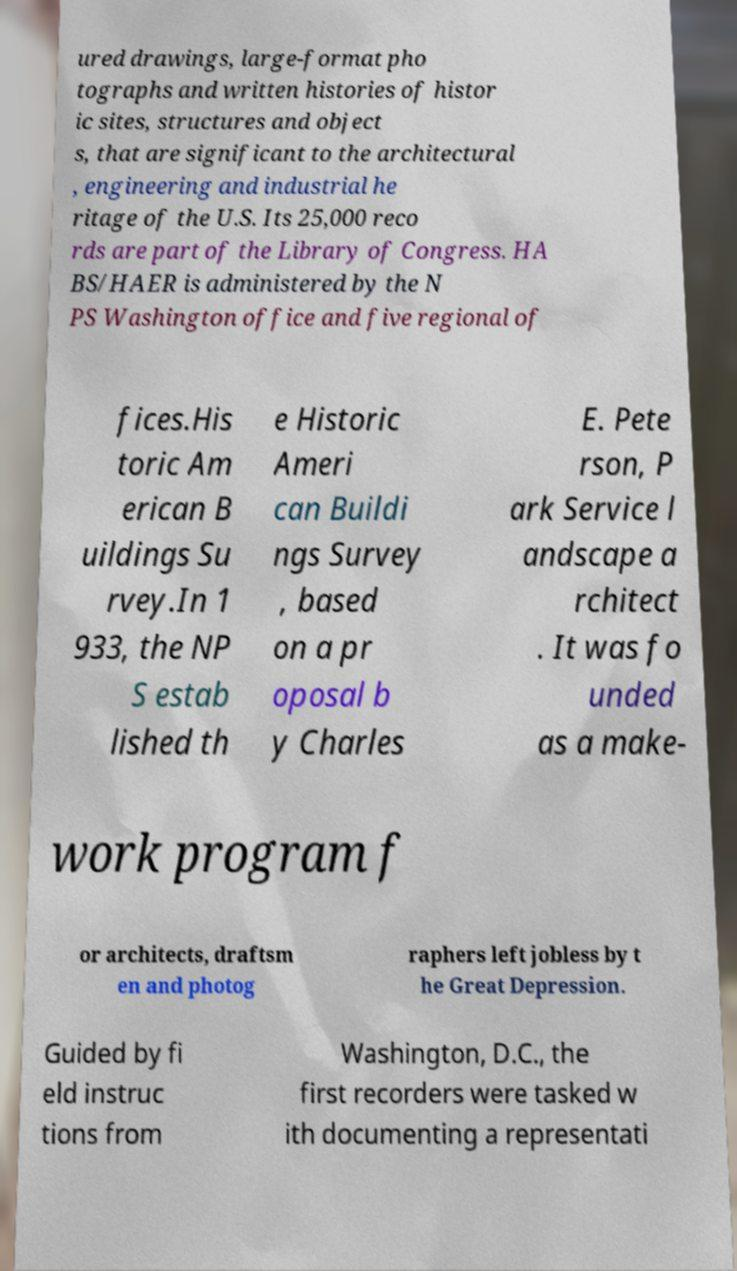Could you extract and type out the text from this image? ured drawings, large-format pho tographs and written histories of histor ic sites, structures and object s, that are significant to the architectural , engineering and industrial he ritage of the U.S. Its 25,000 reco rds are part of the Library of Congress. HA BS/HAER is administered by the N PS Washington office and five regional of fices.His toric Am erican B uildings Su rvey.In 1 933, the NP S estab lished th e Historic Ameri can Buildi ngs Survey , based on a pr oposal b y Charles E. Pete rson, P ark Service l andscape a rchitect . It was fo unded as a make- work program f or architects, draftsm en and photog raphers left jobless by t he Great Depression. Guided by fi eld instruc tions from Washington, D.C., the first recorders were tasked w ith documenting a representati 